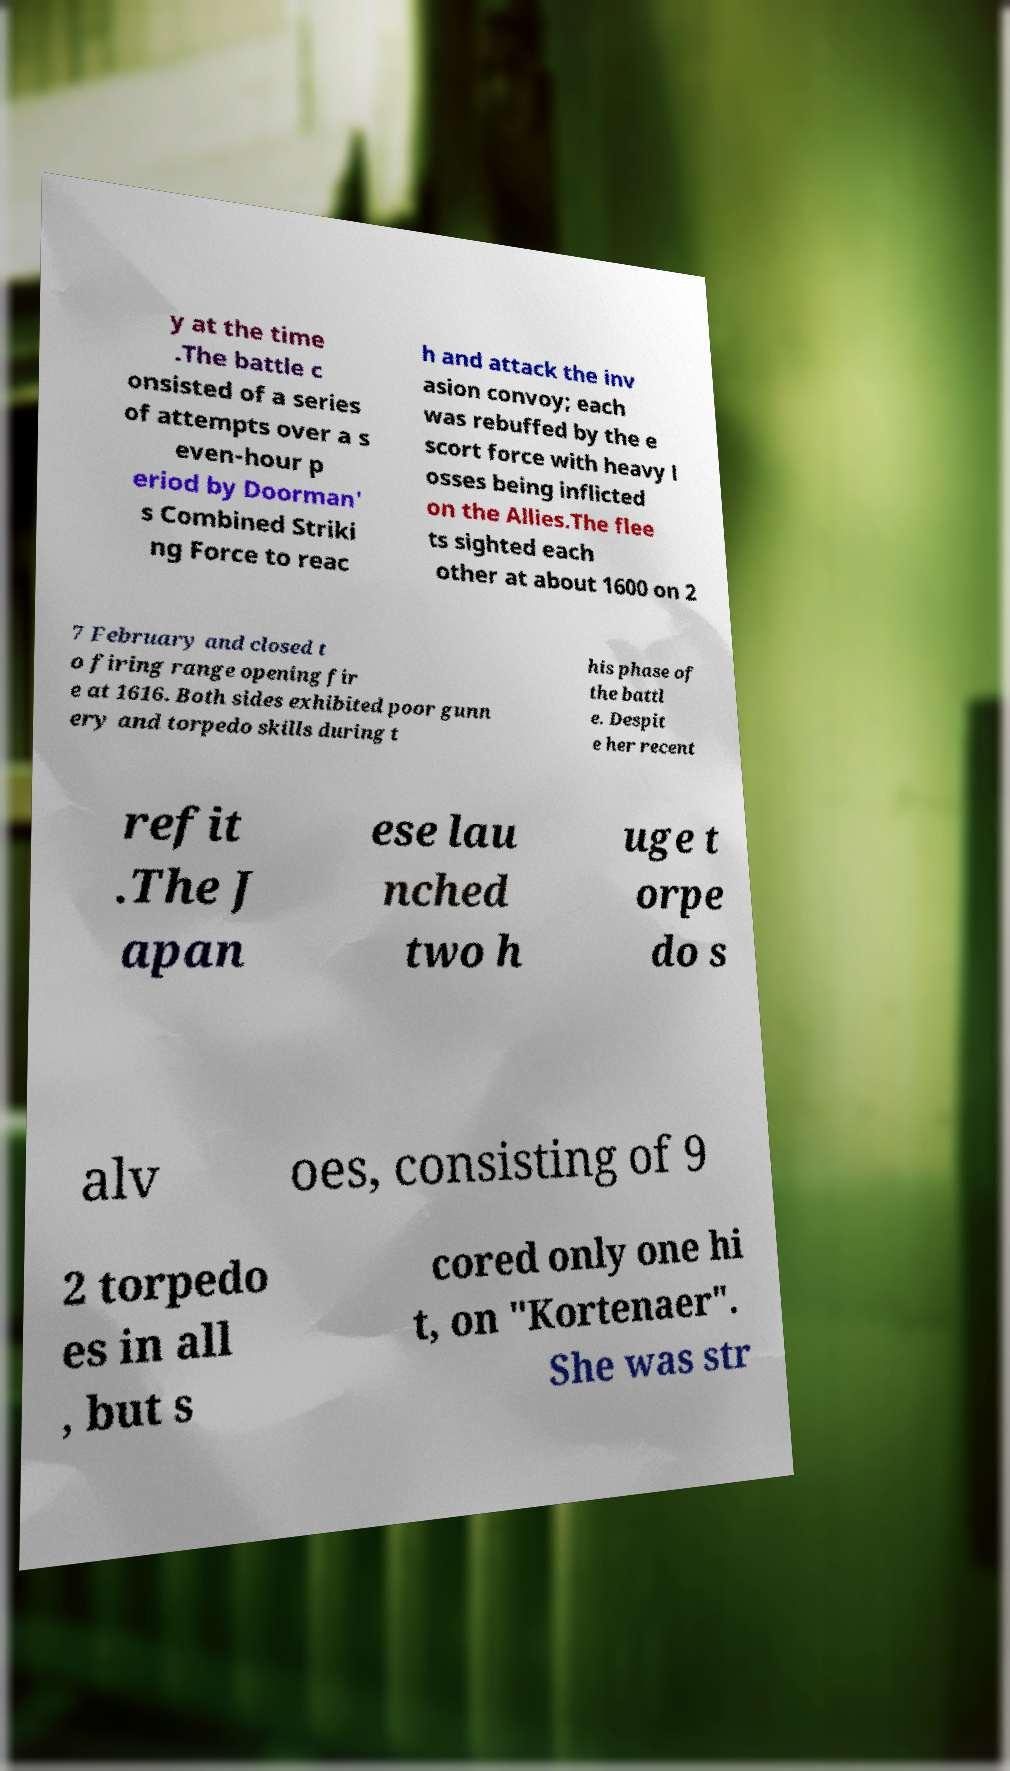What messages or text are displayed in this image? I need them in a readable, typed format. y at the time .The battle c onsisted of a series of attempts over a s even-hour p eriod by Doorman' s Combined Striki ng Force to reac h and attack the inv asion convoy; each was rebuffed by the e scort force with heavy l osses being inflicted on the Allies.The flee ts sighted each other at about 1600 on 2 7 February and closed t o firing range opening fir e at 1616. Both sides exhibited poor gunn ery and torpedo skills during t his phase of the battl e. Despit e her recent refit .The J apan ese lau nched two h uge t orpe do s alv oes, consisting of 9 2 torpedo es in all , but s cored only one hi t, on "Kortenaer". She was str 